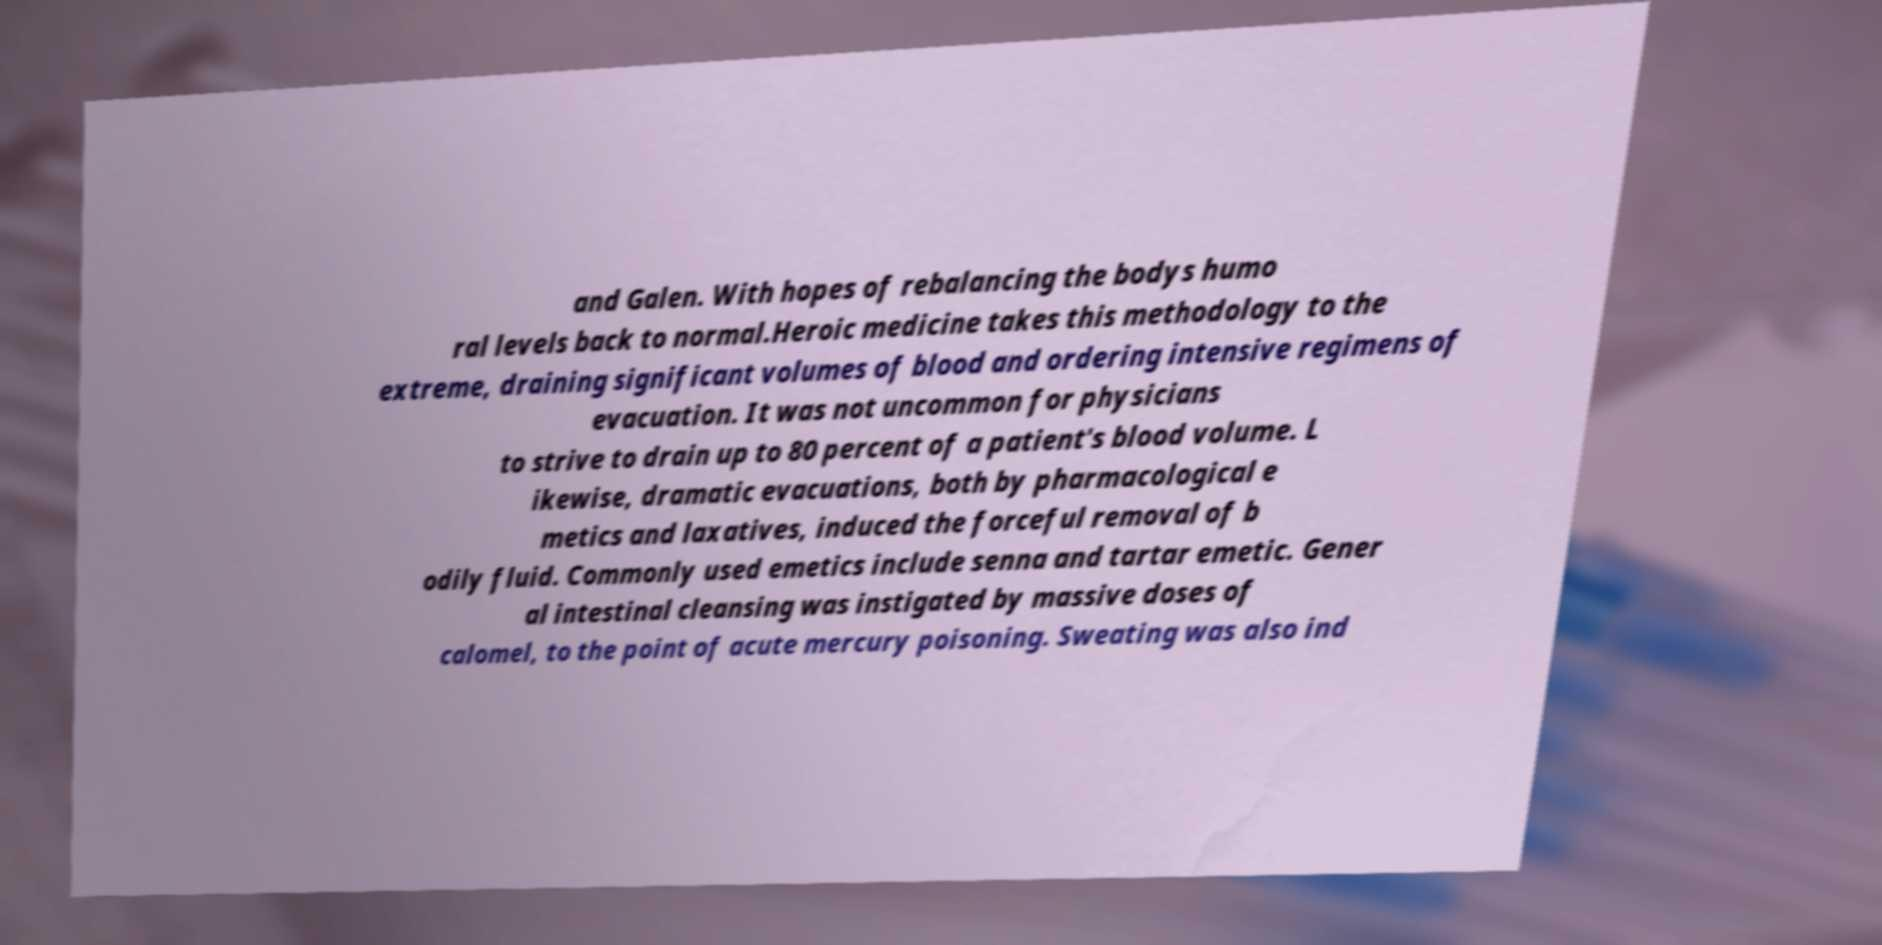Can you accurately transcribe the text from the provided image for me? and Galen. With hopes of rebalancing the bodys humo ral levels back to normal.Heroic medicine takes this methodology to the extreme, draining significant volumes of blood and ordering intensive regimens of evacuation. It was not uncommon for physicians to strive to drain up to 80 percent of a patient's blood volume. L ikewise, dramatic evacuations, both by pharmacological e metics and laxatives, induced the forceful removal of b odily fluid. Commonly used emetics include senna and tartar emetic. Gener al intestinal cleansing was instigated by massive doses of calomel, to the point of acute mercury poisoning. Sweating was also ind 